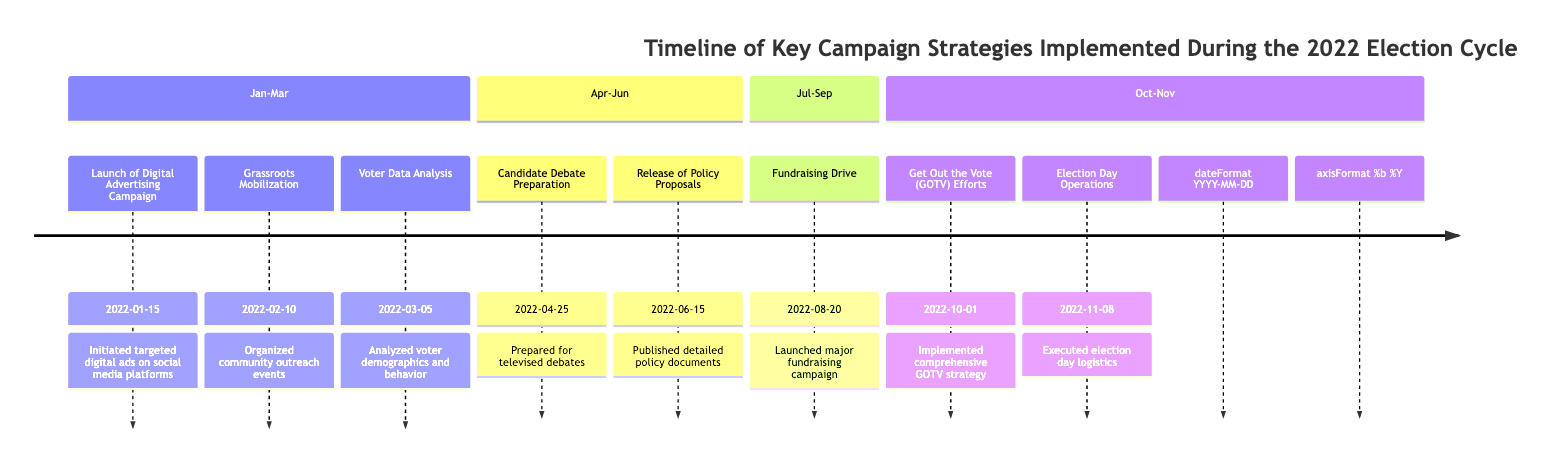What is the first strategy implemented in the timeline? The first strategy listed in the timeline is "Launch of Digital Advertising Campaign," which is dated January 15, 2022.
Answer: Launch of Digital Advertising Campaign How many strategies were implemented between April and June? In the section from April to June, there are two strategies listed: "Candidate Debate Preparation" and "Release of Policy Proposals."
Answer: 2 What strategy was implemented on March 5, 2022? On March 5, 2022, the strategy implemented was "Voter Data Analysis." It is specified in the timeline under that date.
Answer: Voter Data Analysis Which strategy is associated with October 1, 2022? The strategy associated with October 1, 2022, is "Get Out the Vote (GOTV) Efforts," which is the strategy implemented on this date according to the timeline.
Answer: Get Out the Vote (GOTV) Efforts What was the last strategy executed before Election Day? The last strategy executed before Election Day, according to the timeline, was "Get Out the Vote (GOTV) Efforts," which took place on October 1, 2022.
Answer: Get Out the Vote (GOTV) Efforts How many months did the campaign span from January 2022 until Election Day? From January 15, 2022, to November 8, 2022, is a span of approximately 10 months, given that the timeline starts in mid-January and ends in early November.
Answer: 10 months Which campaign strategy came immediately after the "Grassroots Mobilization"? The campaign strategy that came immediately after "Grassroots Mobilization," which took place on February 10, 2022, is "Voter Data Analysis," implemented on March 5, 2022.
Answer: Voter Data Analysis What key event is scheduled for November 8, 2022? The key event scheduled for November 8, 2022, is "Election Day Operations," which includes logistics and monitoring on the actual election day.
Answer: Election Day Operations 